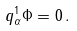Convert formula to latex. <formula><loc_0><loc_0><loc_500><loc_500>q ^ { 1 } _ { \alpha } \Phi = 0 \, .</formula> 